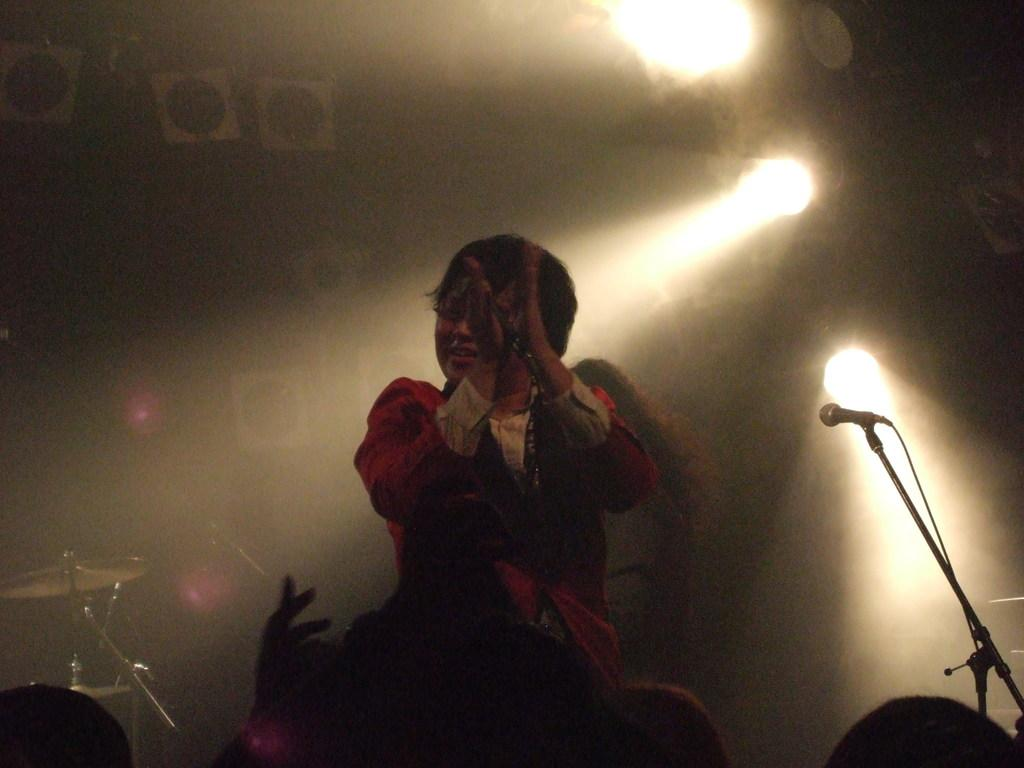What is the main subject of the image? There is a person in the image. What is the person doing in the image? The person is clapping their hands. What object is present in the image that is typically used for amplifying sound? There is a microphone in the image. What can be seen in the background of the image? There is a board and a light in the background of the image. What type of cream is being spread on the board in the image? There is no cream or any activity involving cream in the image. 